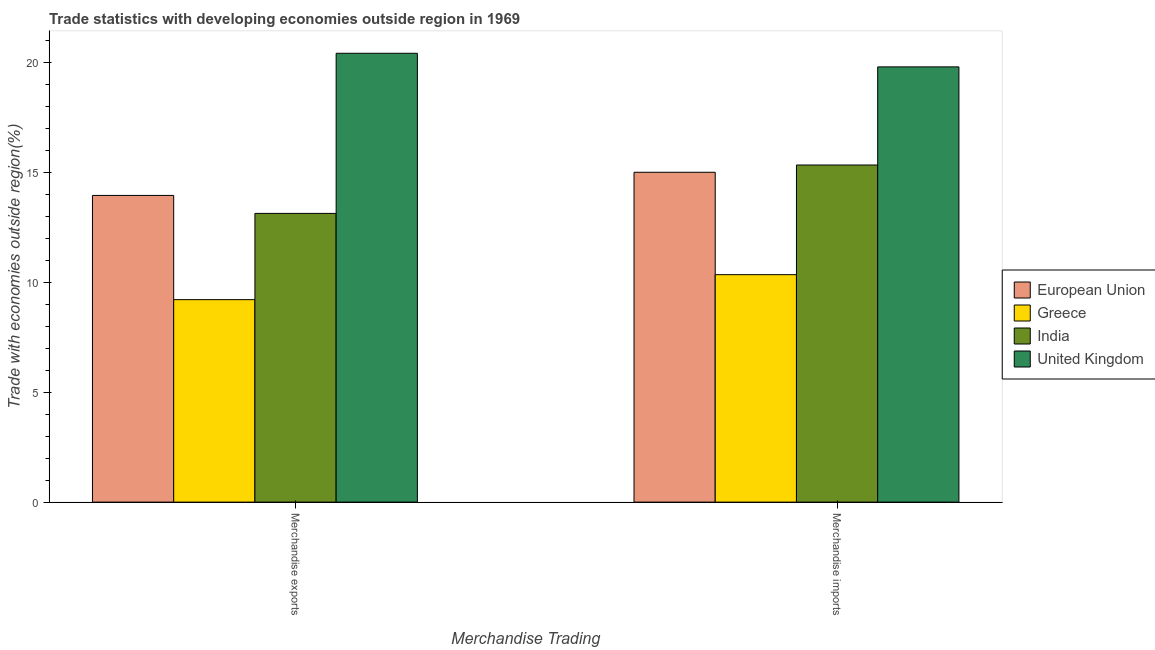How many groups of bars are there?
Provide a succinct answer. 2. Are the number of bars on each tick of the X-axis equal?
Provide a succinct answer. Yes. What is the merchandise exports in European Union?
Provide a succinct answer. 13.96. Across all countries, what is the maximum merchandise imports?
Offer a terse response. 19.81. Across all countries, what is the minimum merchandise exports?
Your response must be concise. 9.21. In which country was the merchandise imports maximum?
Offer a terse response. United Kingdom. What is the total merchandise exports in the graph?
Provide a short and direct response. 56.73. What is the difference between the merchandise imports in United Kingdom and that in India?
Offer a very short reply. 4.46. What is the difference between the merchandise imports in India and the merchandise exports in United Kingdom?
Offer a terse response. -5.08. What is the average merchandise exports per country?
Offer a very short reply. 14.18. What is the difference between the merchandise exports and merchandise imports in Greece?
Provide a succinct answer. -1.14. What is the ratio of the merchandise imports in India to that in European Union?
Your response must be concise. 1.02. In how many countries, is the merchandise exports greater than the average merchandise exports taken over all countries?
Provide a succinct answer. 1. What does the 2nd bar from the left in Merchandise imports represents?
Provide a succinct answer. Greece. Are the values on the major ticks of Y-axis written in scientific E-notation?
Your response must be concise. No. Where does the legend appear in the graph?
Your response must be concise. Center right. How many legend labels are there?
Your response must be concise. 4. How are the legend labels stacked?
Your answer should be compact. Vertical. What is the title of the graph?
Make the answer very short. Trade statistics with developing economies outside region in 1969. Does "Montenegro" appear as one of the legend labels in the graph?
Give a very brief answer. No. What is the label or title of the X-axis?
Make the answer very short. Merchandise Trading. What is the label or title of the Y-axis?
Make the answer very short. Trade with economies outside region(%). What is the Trade with economies outside region(%) of European Union in Merchandise exports?
Provide a short and direct response. 13.96. What is the Trade with economies outside region(%) in Greece in Merchandise exports?
Provide a succinct answer. 9.21. What is the Trade with economies outside region(%) in India in Merchandise exports?
Offer a terse response. 13.14. What is the Trade with economies outside region(%) of United Kingdom in Merchandise exports?
Your answer should be very brief. 20.43. What is the Trade with economies outside region(%) of European Union in Merchandise imports?
Your response must be concise. 15.01. What is the Trade with economies outside region(%) of Greece in Merchandise imports?
Your response must be concise. 10.35. What is the Trade with economies outside region(%) in India in Merchandise imports?
Offer a terse response. 15.34. What is the Trade with economies outside region(%) of United Kingdom in Merchandise imports?
Your answer should be compact. 19.81. Across all Merchandise Trading, what is the maximum Trade with economies outside region(%) of European Union?
Ensure brevity in your answer.  15.01. Across all Merchandise Trading, what is the maximum Trade with economies outside region(%) of Greece?
Your response must be concise. 10.35. Across all Merchandise Trading, what is the maximum Trade with economies outside region(%) of India?
Your response must be concise. 15.34. Across all Merchandise Trading, what is the maximum Trade with economies outside region(%) in United Kingdom?
Offer a terse response. 20.43. Across all Merchandise Trading, what is the minimum Trade with economies outside region(%) in European Union?
Provide a succinct answer. 13.96. Across all Merchandise Trading, what is the minimum Trade with economies outside region(%) of Greece?
Your answer should be very brief. 9.21. Across all Merchandise Trading, what is the minimum Trade with economies outside region(%) in India?
Provide a succinct answer. 13.14. Across all Merchandise Trading, what is the minimum Trade with economies outside region(%) in United Kingdom?
Make the answer very short. 19.81. What is the total Trade with economies outside region(%) of European Union in the graph?
Provide a short and direct response. 28.97. What is the total Trade with economies outside region(%) in Greece in the graph?
Offer a very short reply. 19.56. What is the total Trade with economies outside region(%) of India in the graph?
Ensure brevity in your answer.  28.48. What is the total Trade with economies outside region(%) of United Kingdom in the graph?
Offer a terse response. 40.23. What is the difference between the Trade with economies outside region(%) of European Union in Merchandise exports and that in Merchandise imports?
Offer a terse response. -1.05. What is the difference between the Trade with economies outside region(%) in Greece in Merchandise exports and that in Merchandise imports?
Provide a short and direct response. -1.14. What is the difference between the Trade with economies outside region(%) in India in Merchandise exports and that in Merchandise imports?
Your answer should be compact. -2.2. What is the difference between the Trade with economies outside region(%) of United Kingdom in Merchandise exports and that in Merchandise imports?
Keep it short and to the point. 0.62. What is the difference between the Trade with economies outside region(%) in European Union in Merchandise exports and the Trade with economies outside region(%) in Greece in Merchandise imports?
Your answer should be very brief. 3.61. What is the difference between the Trade with economies outside region(%) in European Union in Merchandise exports and the Trade with economies outside region(%) in India in Merchandise imports?
Provide a succinct answer. -1.38. What is the difference between the Trade with economies outside region(%) in European Union in Merchandise exports and the Trade with economies outside region(%) in United Kingdom in Merchandise imports?
Provide a short and direct response. -5.85. What is the difference between the Trade with economies outside region(%) of Greece in Merchandise exports and the Trade with economies outside region(%) of India in Merchandise imports?
Give a very brief answer. -6.13. What is the difference between the Trade with economies outside region(%) in Greece in Merchandise exports and the Trade with economies outside region(%) in United Kingdom in Merchandise imports?
Give a very brief answer. -10.59. What is the difference between the Trade with economies outside region(%) of India in Merchandise exports and the Trade with economies outside region(%) of United Kingdom in Merchandise imports?
Make the answer very short. -6.67. What is the average Trade with economies outside region(%) of European Union per Merchandise Trading?
Offer a very short reply. 14.48. What is the average Trade with economies outside region(%) in Greece per Merchandise Trading?
Offer a very short reply. 9.78. What is the average Trade with economies outside region(%) of India per Merchandise Trading?
Offer a terse response. 14.24. What is the average Trade with economies outside region(%) of United Kingdom per Merchandise Trading?
Your answer should be compact. 20.12. What is the difference between the Trade with economies outside region(%) in European Union and Trade with economies outside region(%) in Greece in Merchandise exports?
Provide a succinct answer. 4.74. What is the difference between the Trade with economies outside region(%) of European Union and Trade with economies outside region(%) of India in Merchandise exports?
Keep it short and to the point. 0.82. What is the difference between the Trade with economies outside region(%) of European Union and Trade with economies outside region(%) of United Kingdom in Merchandise exports?
Your answer should be very brief. -6.47. What is the difference between the Trade with economies outside region(%) of Greece and Trade with economies outside region(%) of India in Merchandise exports?
Keep it short and to the point. -3.92. What is the difference between the Trade with economies outside region(%) in Greece and Trade with economies outside region(%) in United Kingdom in Merchandise exports?
Keep it short and to the point. -11.21. What is the difference between the Trade with economies outside region(%) of India and Trade with economies outside region(%) of United Kingdom in Merchandise exports?
Your answer should be very brief. -7.29. What is the difference between the Trade with economies outside region(%) in European Union and Trade with economies outside region(%) in Greece in Merchandise imports?
Keep it short and to the point. 4.66. What is the difference between the Trade with economies outside region(%) in European Union and Trade with economies outside region(%) in India in Merchandise imports?
Ensure brevity in your answer.  -0.33. What is the difference between the Trade with economies outside region(%) in European Union and Trade with economies outside region(%) in United Kingdom in Merchandise imports?
Keep it short and to the point. -4.8. What is the difference between the Trade with economies outside region(%) of Greece and Trade with economies outside region(%) of India in Merchandise imports?
Provide a short and direct response. -4.99. What is the difference between the Trade with economies outside region(%) of Greece and Trade with economies outside region(%) of United Kingdom in Merchandise imports?
Your response must be concise. -9.45. What is the difference between the Trade with economies outside region(%) in India and Trade with economies outside region(%) in United Kingdom in Merchandise imports?
Provide a succinct answer. -4.46. What is the ratio of the Trade with economies outside region(%) in European Union in Merchandise exports to that in Merchandise imports?
Keep it short and to the point. 0.93. What is the ratio of the Trade with economies outside region(%) of Greece in Merchandise exports to that in Merchandise imports?
Keep it short and to the point. 0.89. What is the ratio of the Trade with economies outside region(%) in India in Merchandise exports to that in Merchandise imports?
Provide a succinct answer. 0.86. What is the ratio of the Trade with economies outside region(%) of United Kingdom in Merchandise exports to that in Merchandise imports?
Your answer should be compact. 1.03. What is the difference between the highest and the second highest Trade with economies outside region(%) in European Union?
Keep it short and to the point. 1.05. What is the difference between the highest and the second highest Trade with economies outside region(%) of Greece?
Offer a terse response. 1.14. What is the difference between the highest and the second highest Trade with economies outside region(%) of India?
Your answer should be compact. 2.2. What is the difference between the highest and the second highest Trade with economies outside region(%) of United Kingdom?
Ensure brevity in your answer.  0.62. What is the difference between the highest and the lowest Trade with economies outside region(%) in European Union?
Your answer should be very brief. 1.05. What is the difference between the highest and the lowest Trade with economies outside region(%) of Greece?
Your answer should be very brief. 1.14. What is the difference between the highest and the lowest Trade with economies outside region(%) of India?
Your answer should be compact. 2.2. What is the difference between the highest and the lowest Trade with economies outside region(%) in United Kingdom?
Your response must be concise. 0.62. 